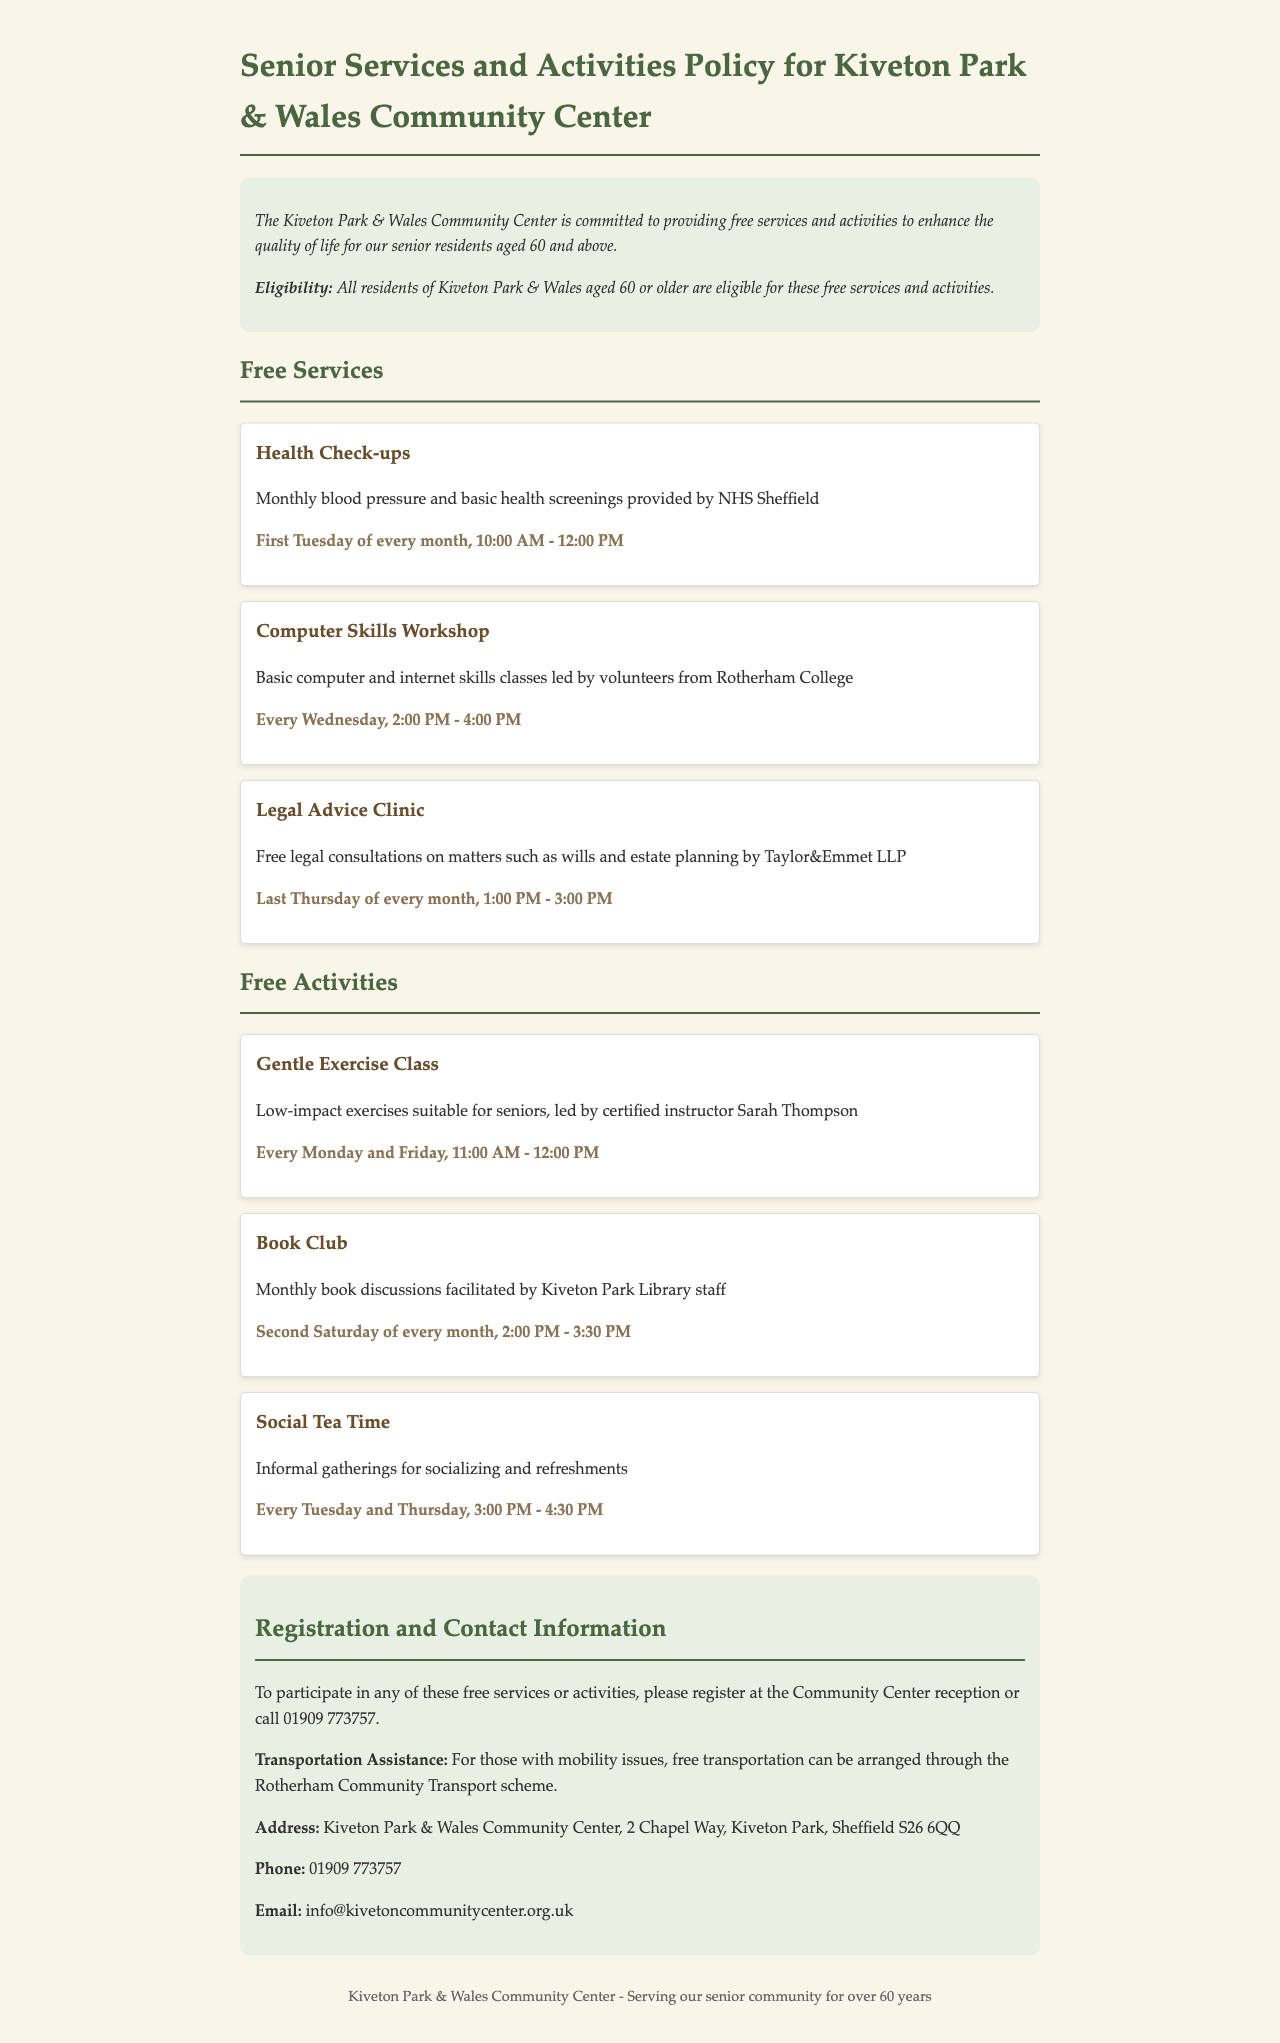What is the age eligibility for the free services? The document states that all residents of Kiveton Park & Wales aged 60 or older are eligible for these free services and activities.
Answer: 60 When are the health check-ups held? The frequency of health check-ups is mentioned in the document as being on the first Tuesday of every month from 10:00 AM to 12:00 PM.
Answer: First Tuesday of every month, 10:00 AM - 12:00 PM Who leads the computer skills workshop? The document specifies that the computer skills workshop is led by volunteers from Rotherham College.
Answer: Rotherham College What is the name of the instructor for the gentle exercise class? The instructor for the gentle exercise class is named in the document as Sarah Thompson.
Answer: Sarah Thompson How often does the book club meet? The document indicates that the book club meets once a month, specifically on the second Saturday of every month from 2:00 PM to 3:30 PM.
Answer: Monthly What type of assistance is offered for those with mobility issues? The document mentions that free transportation can be arranged for those with mobility issues through the Rotherham Community Transport scheme.
Answer: Free transportation How do residents register for the services? Residents can register at the Community Center reception or call a provided phone number to participate in any free services or activities.
Answer: At the Community Center reception or call 01909 773757 When is the social tea time scheduled? The document outlines the schedule for social tea time as every Tuesday and Thursday from 3:00 PM to 4:30 PM.
Answer: Every Tuesday and Thursday, 3:00 PM - 4:30 PM 